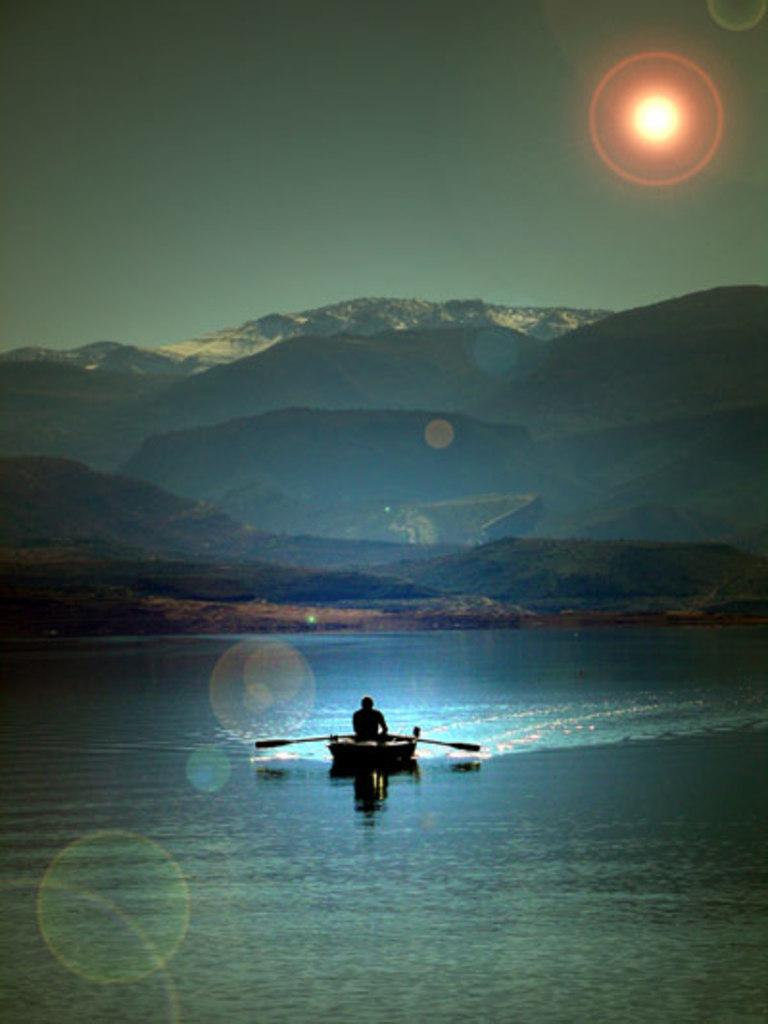What is the person in the image doing? The person is sitting in a boat. Where is the boat located? The boat is on the water. What can be seen on either side of the person in the boat? There are sticks on either side of the person. What is visible in the background of the image? There are mountains in the background of the image. What type of attention-grabbing substance is stored in the jar on the boat? There is no jar present in the image, and therefore no substance can be observed. 